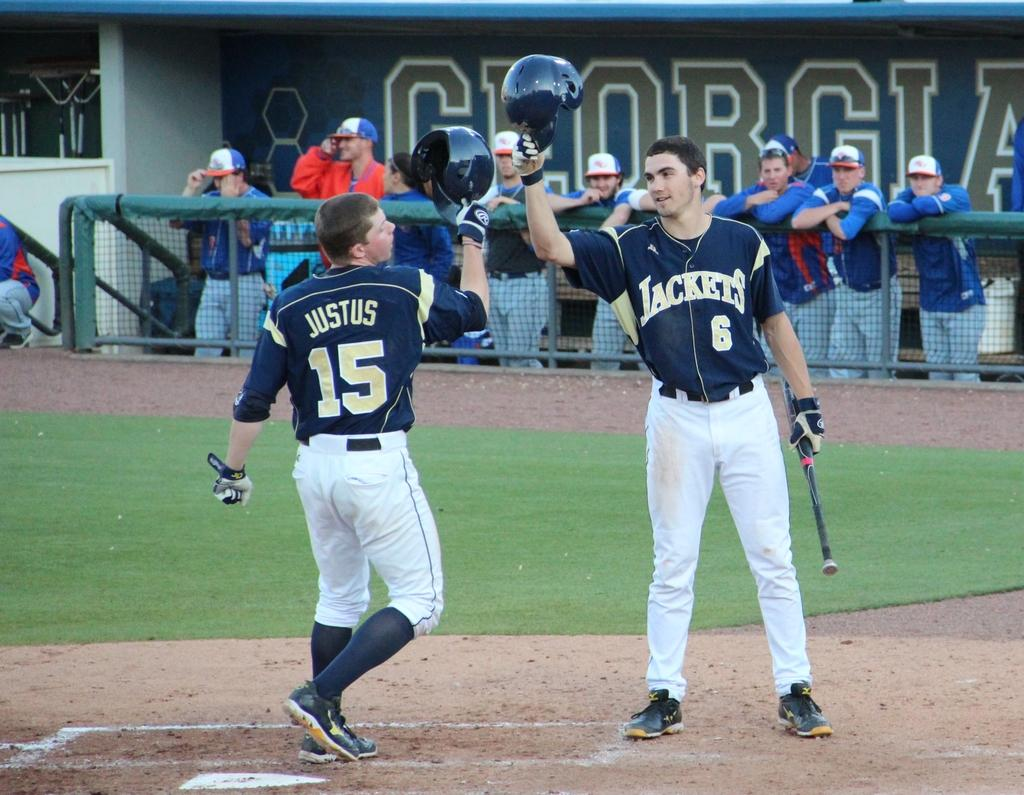<image>
Render a clear and concise summary of the photo. Justus raises his helmet to click it with another player's helmet. 